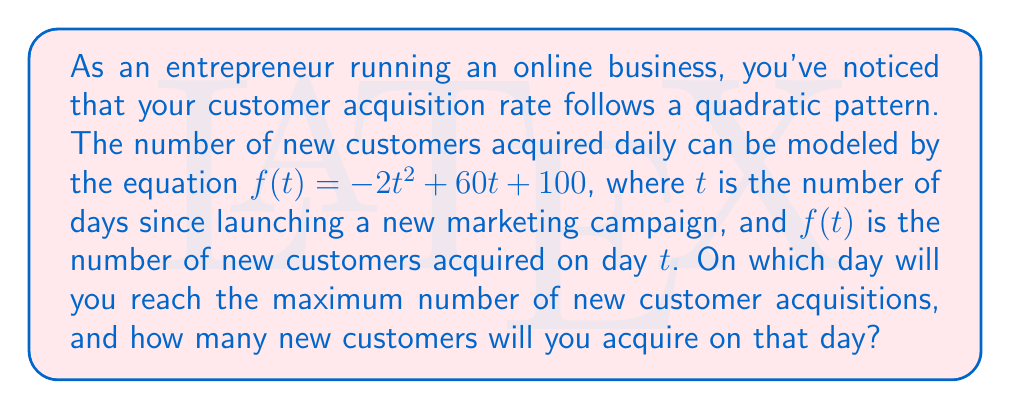What is the answer to this math problem? To solve this problem, we need to follow these steps:

1) The given quadratic equation is in the form $f(t) = -2t^2 + 60t + 100$

2) For a quadratic function $f(t) = at^2 + bt + c$, the t-coordinate of the vertex (which gives the maximum or minimum point) is given by the formula $t = -\frac{b}{2a}$

3) In this case, $a = -2$ and $b = 60$. Let's substitute these values:

   $t = -\frac{60}{2(-2)} = -\frac{60}{-4} = 15$

4) This means the maximum number of new customer acquisitions will occur on day 15 of the marketing campaign.

5) To find the number of new customers acquired on this day, we need to calculate $f(15)$:

   $f(15) = -2(15)^2 + 60(15) + 100$
   $= -2(225) + 900 + 100$
   $= -450 + 900 + 100$
   $= 550$

Therefore, on day 15, you will acquire 550 new customers, which is the maximum daily acquisition for this campaign.
Answer: The maximum number of new customer acquisitions will occur on day 15 of the marketing campaign, with 550 new customers acquired on that day. 